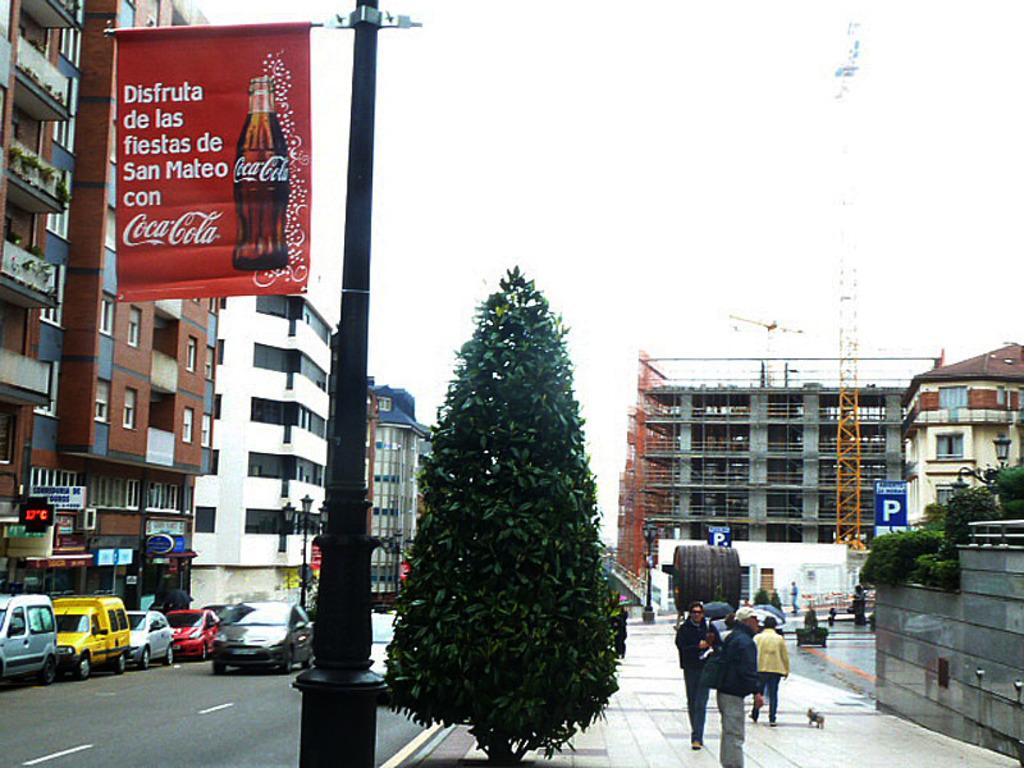What company is advetised on the sign on the pole?
Make the answer very short. Coca cola. 